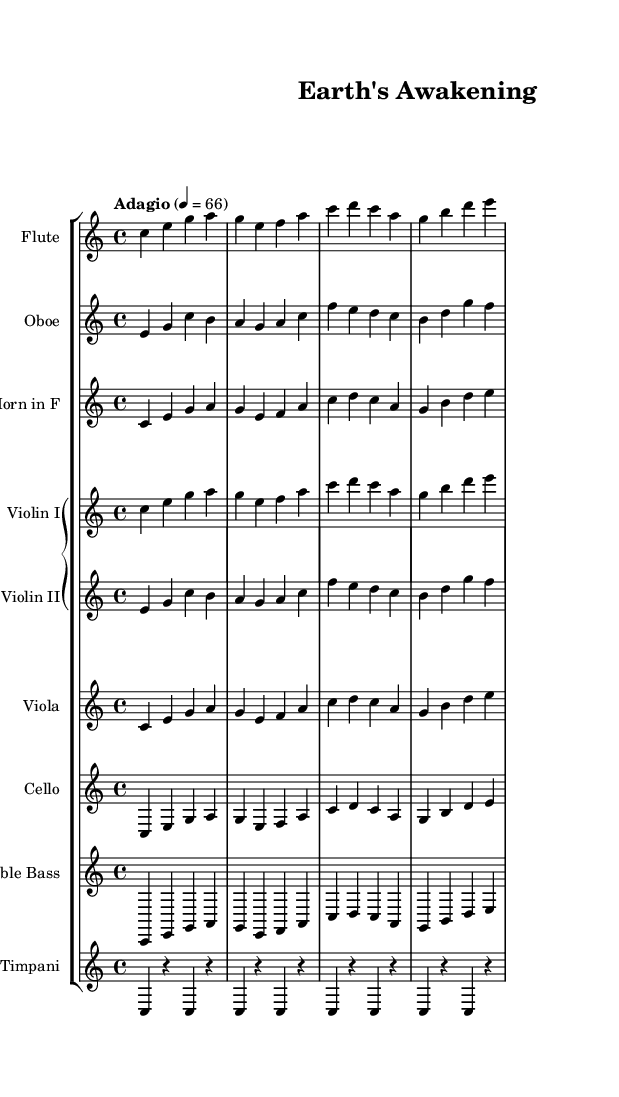What is the key signature of this music? The key signature is C major, which has no sharps or flats indicated at the beginning of the score.
Answer: C major What is the time signature of this music? The time signature is indicated as 4/4, which means there are four beats in each measure and the quarter note gets one beat.
Answer: 4/4 What is the tempo marking given for this piece? The tempo marking of "Adagio" suggests a slow and leisurely pace, which is defined with a metronome marking of 66 beats per minute.
Answer: Adagio Which instruments are featured in this orchestral score? The instruments listed in the score include Flute, Oboe, Horn in F, Violin I, Violin II, Viola, Cello, Double Bass, and Timpani as indicated by the instrument names at the beginning of each staff.
Answer: Flute, Oboe, Horn in F, Violin I, Violin II, Viola, Cello, Double Bass, Timpani How many measures are there in the main theme section? Analyzing the score, there are a total of four measures in the main theme section that is repeated across different instrument lines.
Answer: 4 Which dynamic indication is likely to be inferred from the overall mood of the composition? The gentle and reflective nature of the melodic lines, particularly the use of the Adagio tempo, suggests a dynamic indication of "piano," which means soft.
Answer: Piano 